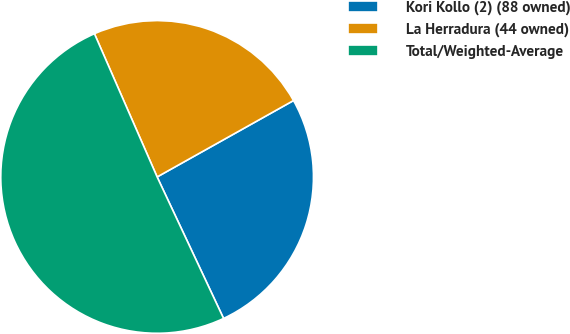Convert chart to OTSL. <chart><loc_0><loc_0><loc_500><loc_500><pie_chart><fcel>Kori Kollo (2) (88 owned)<fcel>La Herradura (44 owned)<fcel>Total/Weighted-Average<nl><fcel>26.14%<fcel>23.44%<fcel>50.42%<nl></chart> 